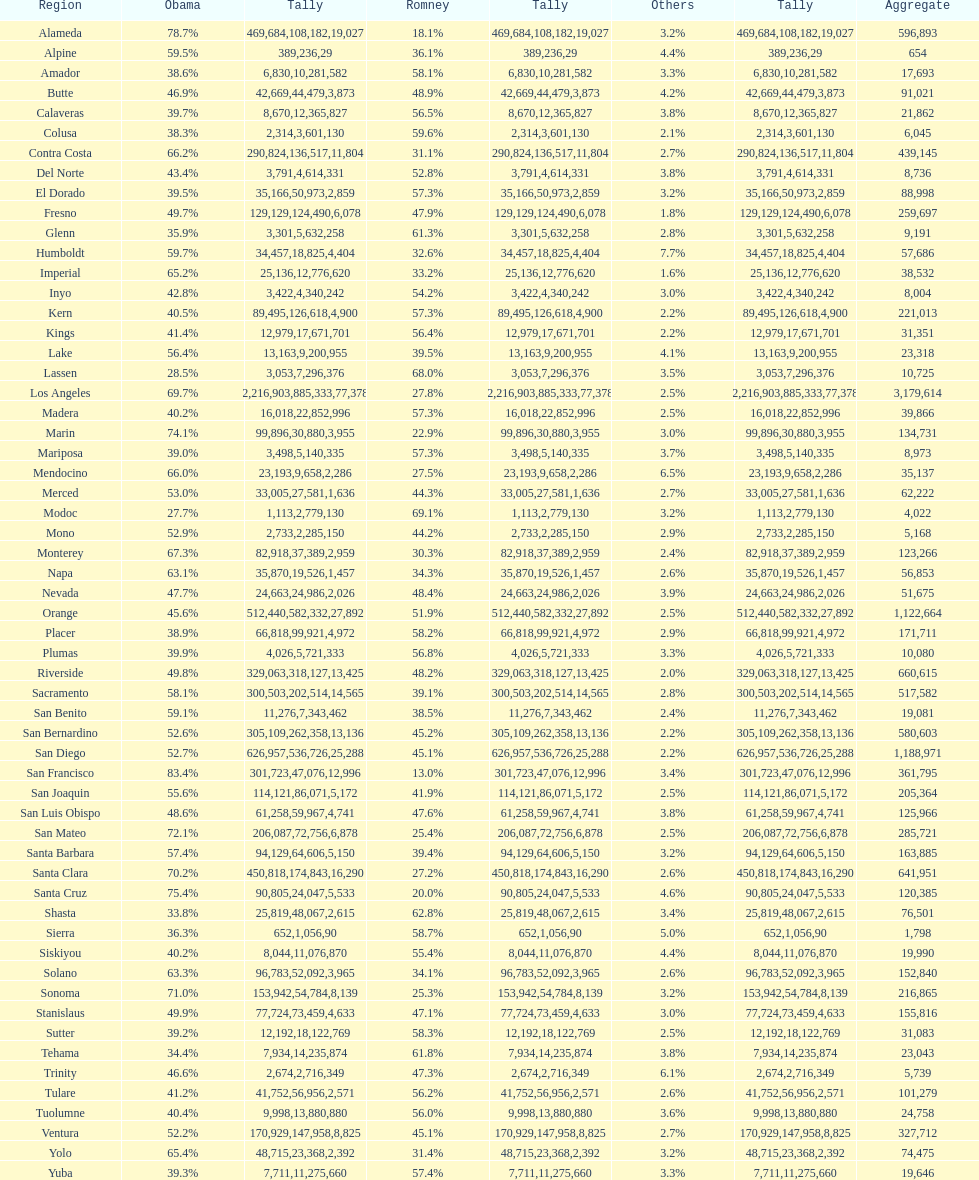Which count had the least number of votes for obama? Modoc. 